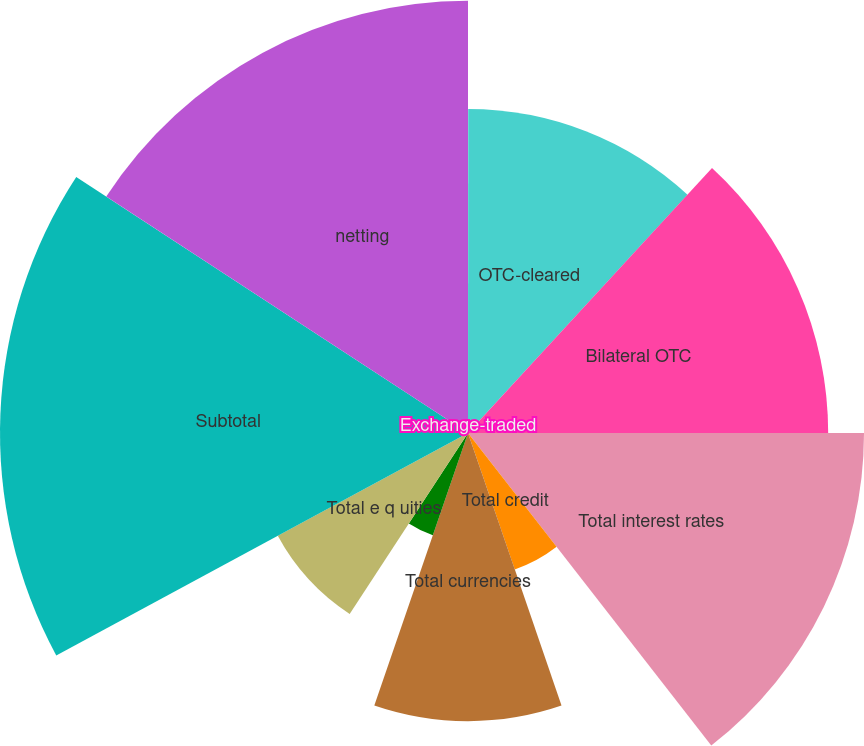Convert chart to OTSL. <chart><loc_0><loc_0><loc_500><loc_500><pie_chart><fcel>Exchange-traded<fcel>OTC-cleared<fcel>Bilateral OTC<fcel>Total interest rates<fcel>Total credit<fcel>Total currencies<fcel>Total commodities<fcel>Total e q uities<fcel>Subtotal<fcel>netting<nl><fcel>0.01%<fcel>11.84%<fcel>13.16%<fcel>14.47%<fcel>5.27%<fcel>10.53%<fcel>3.95%<fcel>7.9%<fcel>17.1%<fcel>15.79%<nl></chart> 